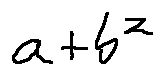<formula> <loc_0><loc_0><loc_500><loc_500>a + b ^ { 2 }</formula> 